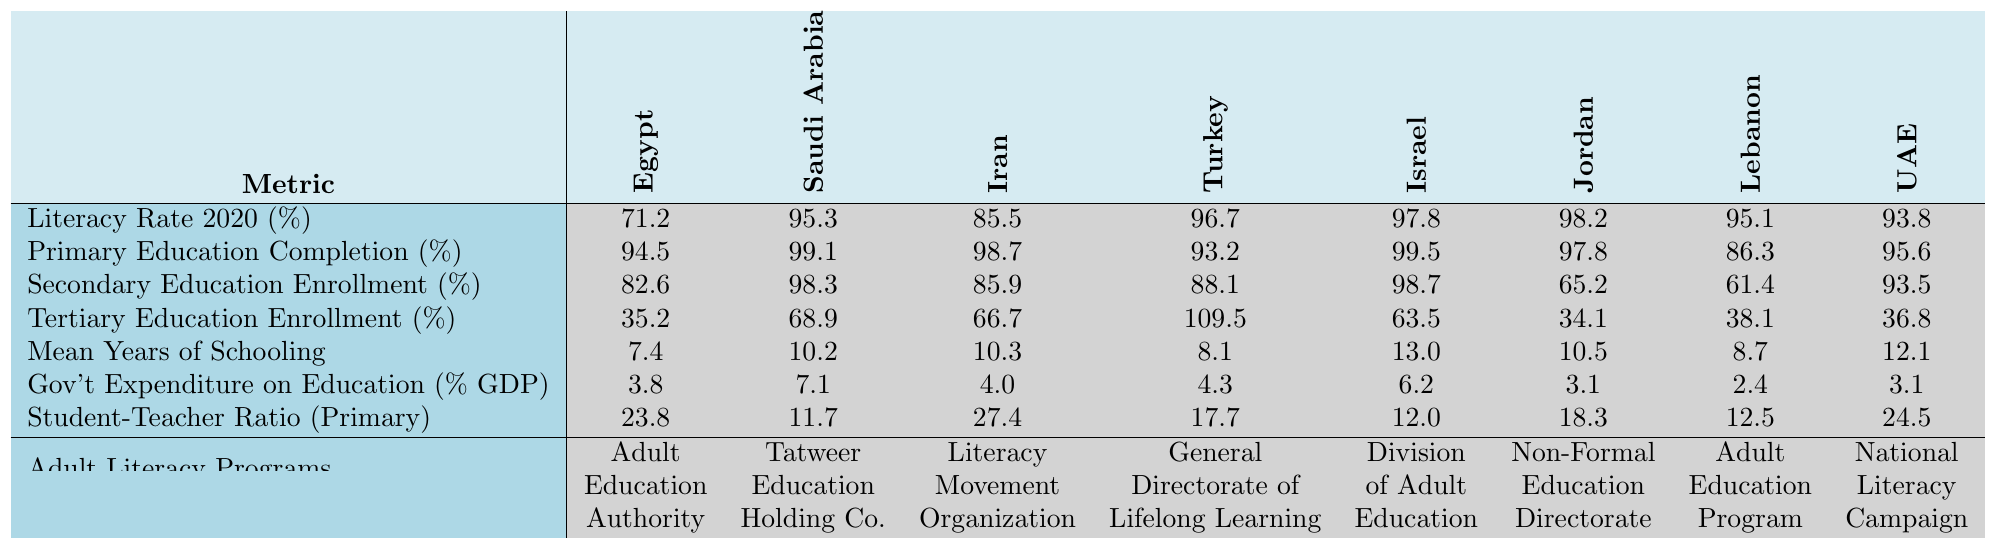What is the literacy rate in Egypt for the year 2020? The table shows that the literacy rate in Egypt for 2020 is listed under the "Literacy Rate 2020 (%)" row, which shows a value of 71.2.
Answer: 71.2% Which country has the highest literacy rate in the table? Looking at the "Literacy Rate 2020 (%)" values, Israel has the highest literacy rate at 97.8%.
Answer: Israel What is the primary education completion rate in Jordan? The completion rate for primary education in Jordan is located in the "Primary Education Completion (%)" row, and it shows a value of 97.8%.
Answer: 97.8% What is the difference in secondary education enrollment rates between Turkey and Saudi Arabia? The secondary education enrollment rate for Turkey is 88.1%, while for Saudi Arabia it is 98.3%. The difference is calculated as 98.3 - 88.1 = 10.2%.
Answer: 10.2% What is the mean years of schooling in Lebanon? According to the table in the "Mean Years of Schooling" row, Lebanon's value is 8.7 years.
Answer: 8.7 Which country has the lowest primary education completion rate? By analyzing the "Primary Education Completion (%)" values, Lebanon has the lowest rate of 86.3%.
Answer: Lebanon Are adult literacy programs available in Iran? The table indicates that there is an adult literacy program called "Literacy Movement Organization" in Iran.
Answer: Yes What is the average student-teacher ratio in the primary education sector among these countries? First, sum the values of the student-teacher ratio: (23.8 + 11.7 + 27.4 + 17.7 + 12.0 + 18.3 + 12.5 + 24.5) = 145.9. There are 8 countries, so the average is 145.9 / 8 = 18.2375, which rounds to 18.2.
Answer: 18.2 Which country spends the highest percentage of its GDP on education? Review the "Gov't Expenditure on Education (% GDP)" row, where Saudi Arabia shows the highest expenditure at 7.1%.
Answer: Saudi Arabia What can you determine about the relationship between literacy rates and government expenditure on education in these countries? A detailed comparison reveals that higher literacy rates often correlate with higher government expenditure on education, as seen with Saudi Arabia and Israel having both high literacy rates and higher spending.
Answer: Positive correlation observed 